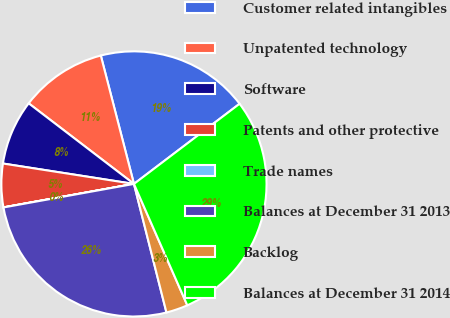Convert chart to OTSL. <chart><loc_0><loc_0><loc_500><loc_500><pie_chart><fcel>Customer related intangibles<fcel>Unpatented technology<fcel>Software<fcel>Patents and other protective<fcel>Trade names<fcel>Balances at December 31 2013<fcel>Backlog<fcel>Balances at December 31 2014<nl><fcel>18.69%<fcel>10.58%<fcel>7.94%<fcel>5.29%<fcel>0.01%<fcel>26.1%<fcel>2.65%<fcel>28.74%<nl></chart> 